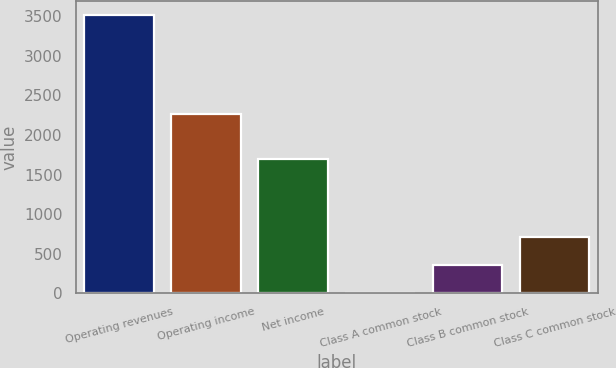Convert chart to OTSL. <chart><loc_0><loc_0><loc_500><loc_500><bar_chart><fcel>Operating revenues<fcel>Operating income<fcel>Net income<fcel>Class A common stock<fcel>Class B common stock<fcel>Class C common stock<nl><fcel>3518<fcel>2262<fcel>1697<fcel>0.69<fcel>352.42<fcel>704.15<nl></chart> 